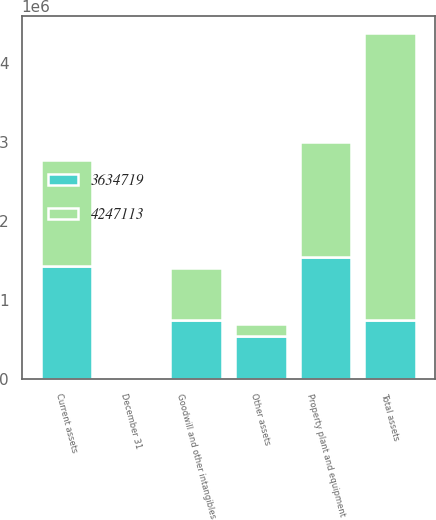Convert chart to OTSL. <chart><loc_0><loc_0><loc_500><loc_500><stacked_bar_chart><ecel><fcel>December 31<fcel>Current assets<fcel>Property plant and equipment<fcel>Goodwill and other intangibles<fcel>Other assets<fcel>Total assets<nl><fcel>4.24711e+06<fcel>2008<fcel>1.34494e+06<fcel>1.45895e+06<fcel>665449<fcel>151561<fcel>3.63472e+06<nl><fcel>3.63472e+06<fcel>2007<fcel>1.42657e+06<fcel>1.53972e+06<fcel>740575<fcel>540249<fcel>740575<nl></chart> 